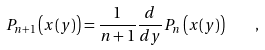<formula> <loc_0><loc_0><loc_500><loc_500>P _ { n + 1 } \left ( x ( y ) \right ) = \frac { 1 } { n + 1 } \frac { d } { d y } P _ { n } \left ( x ( y ) \right ) \quad ,</formula> 